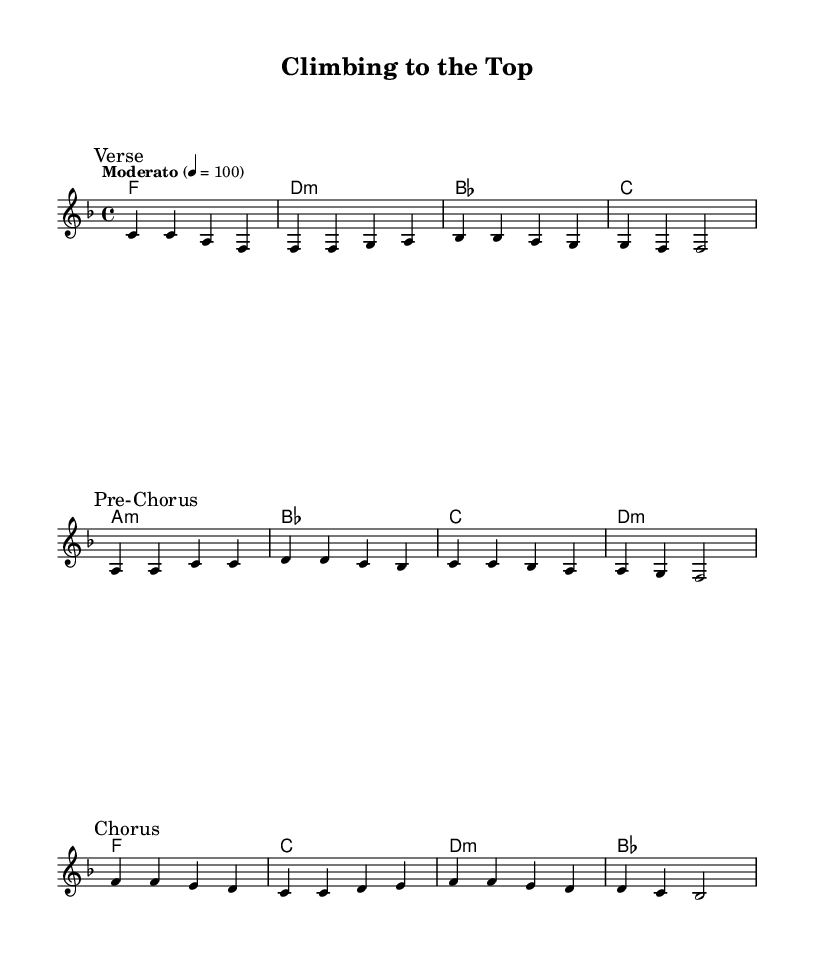What is the key signature of this music? The key signature shown is F major, which has one flat (B flat). This is indicated by the symbols at the beginning of the staff.
Answer: F major What is the time signature of this music? The time signature is 4/4, which can be seen at the beginning of the sheet music, indicating that there are four beats in each measure.
Answer: 4/4 What is the tempo marking for this piece? The tempo marking is "Moderato," indicating a moderate speed for the piece. This is also indicated alongside a metronome marking of 100 beats per minute.
Answer: Moderato What is the first lyric of the verse? The first lyric presented in the verse section of the song is "Worked so hard." This can be found right after the verse mark in the lyric portion of the sheet music.
Answer: Worked so hard How many measures are in the chorus? The chorus section consists of four measures, as seen in the notation, which displays a total of four sets of musical notes organized in time with the lyrics.
Answer: 4 What is the last chord in the harmonies? The last chord in the harmonies section is B flat major, which is visibly marked at the end of the section. It can be identified by its notation within the chord progression.
Answer: B flat What is the basic theme of the lyrics in this piece? The basic theme of the lyrics revolves around achieving professional success and celebrating accomplishments, which can be inferred from phrases in the verse and chorus.
Answer: Success 